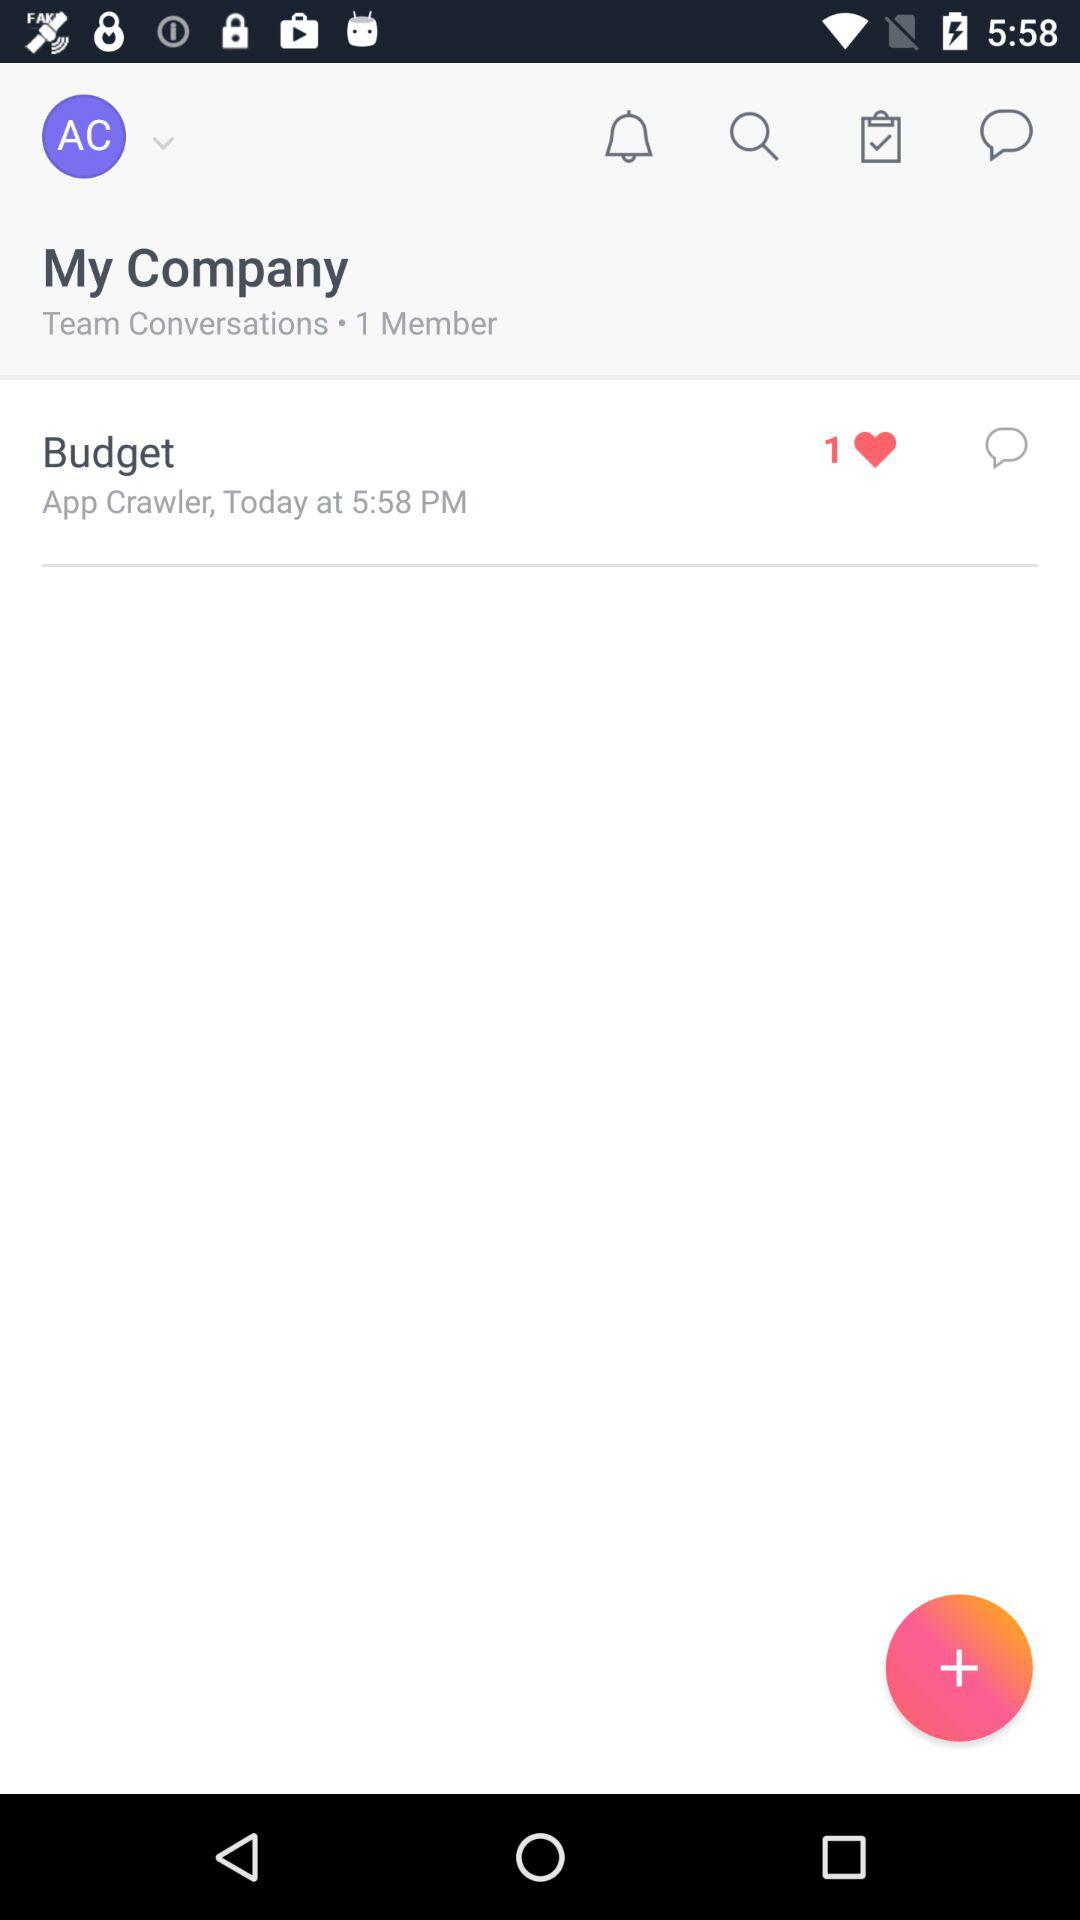What is the given profile name in "Budget"? The given profile name is App Crawler. 